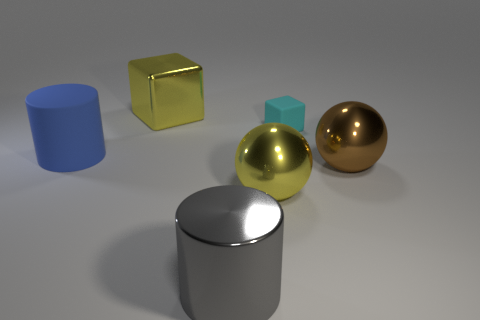What is the shape of the large metal thing to the right of the tiny cyan thing?
Provide a short and direct response. Sphere. Is there a big blue ball made of the same material as the yellow sphere?
Give a very brief answer. No. Does the brown object have the same size as the blue object?
Ensure brevity in your answer.  Yes. What number of cylinders are small cyan objects or brown things?
Provide a short and direct response. 0. What material is the object that is the same color as the large metallic cube?
Your answer should be very brief. Metal. How many big matte things have the same shape as the tiny cyan matte object?
Your response must be concise. 0. Are there more gray cylinders in front of the large gray metal thing than large shiny blocks in front of the brown metallic sphere?
Make the answer very short. No. Do the big sphere to the right of the big yellow shiny sphere and the shiny cylinder have the same color?
Offer a very short reply. No. What is the size of the gray object?
Your response must be concise. Large. What is the material of the cube that is the same size as the brown object?
Your answer should be compact. Metal. 